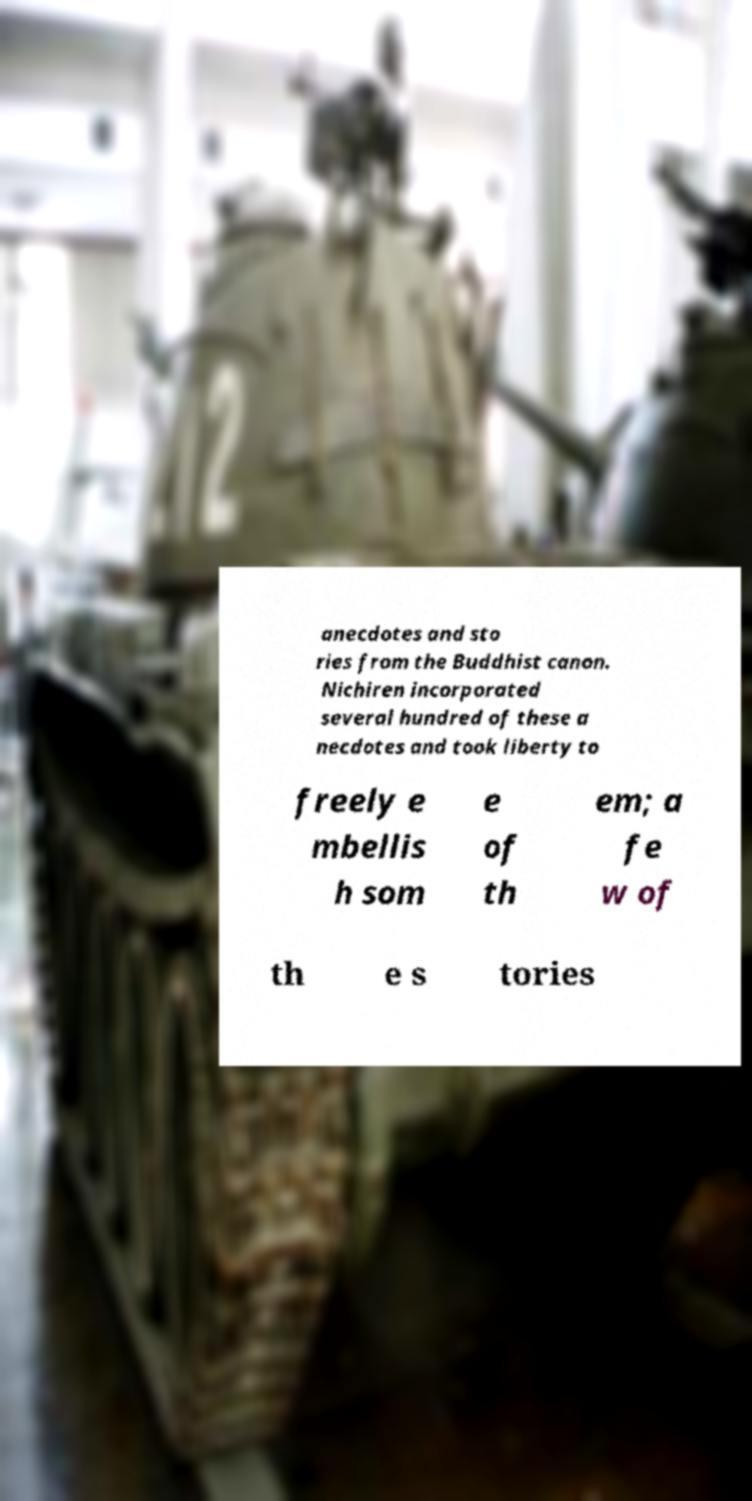Can you accurately transcribe the text from the provided image for me? anecdotes and sto ries from the Buddhist canon. Nichiren incorporated several hundred of these a necdotes and took liberty to freely e mbellis h som e of th em; a fe w of th e s tories 